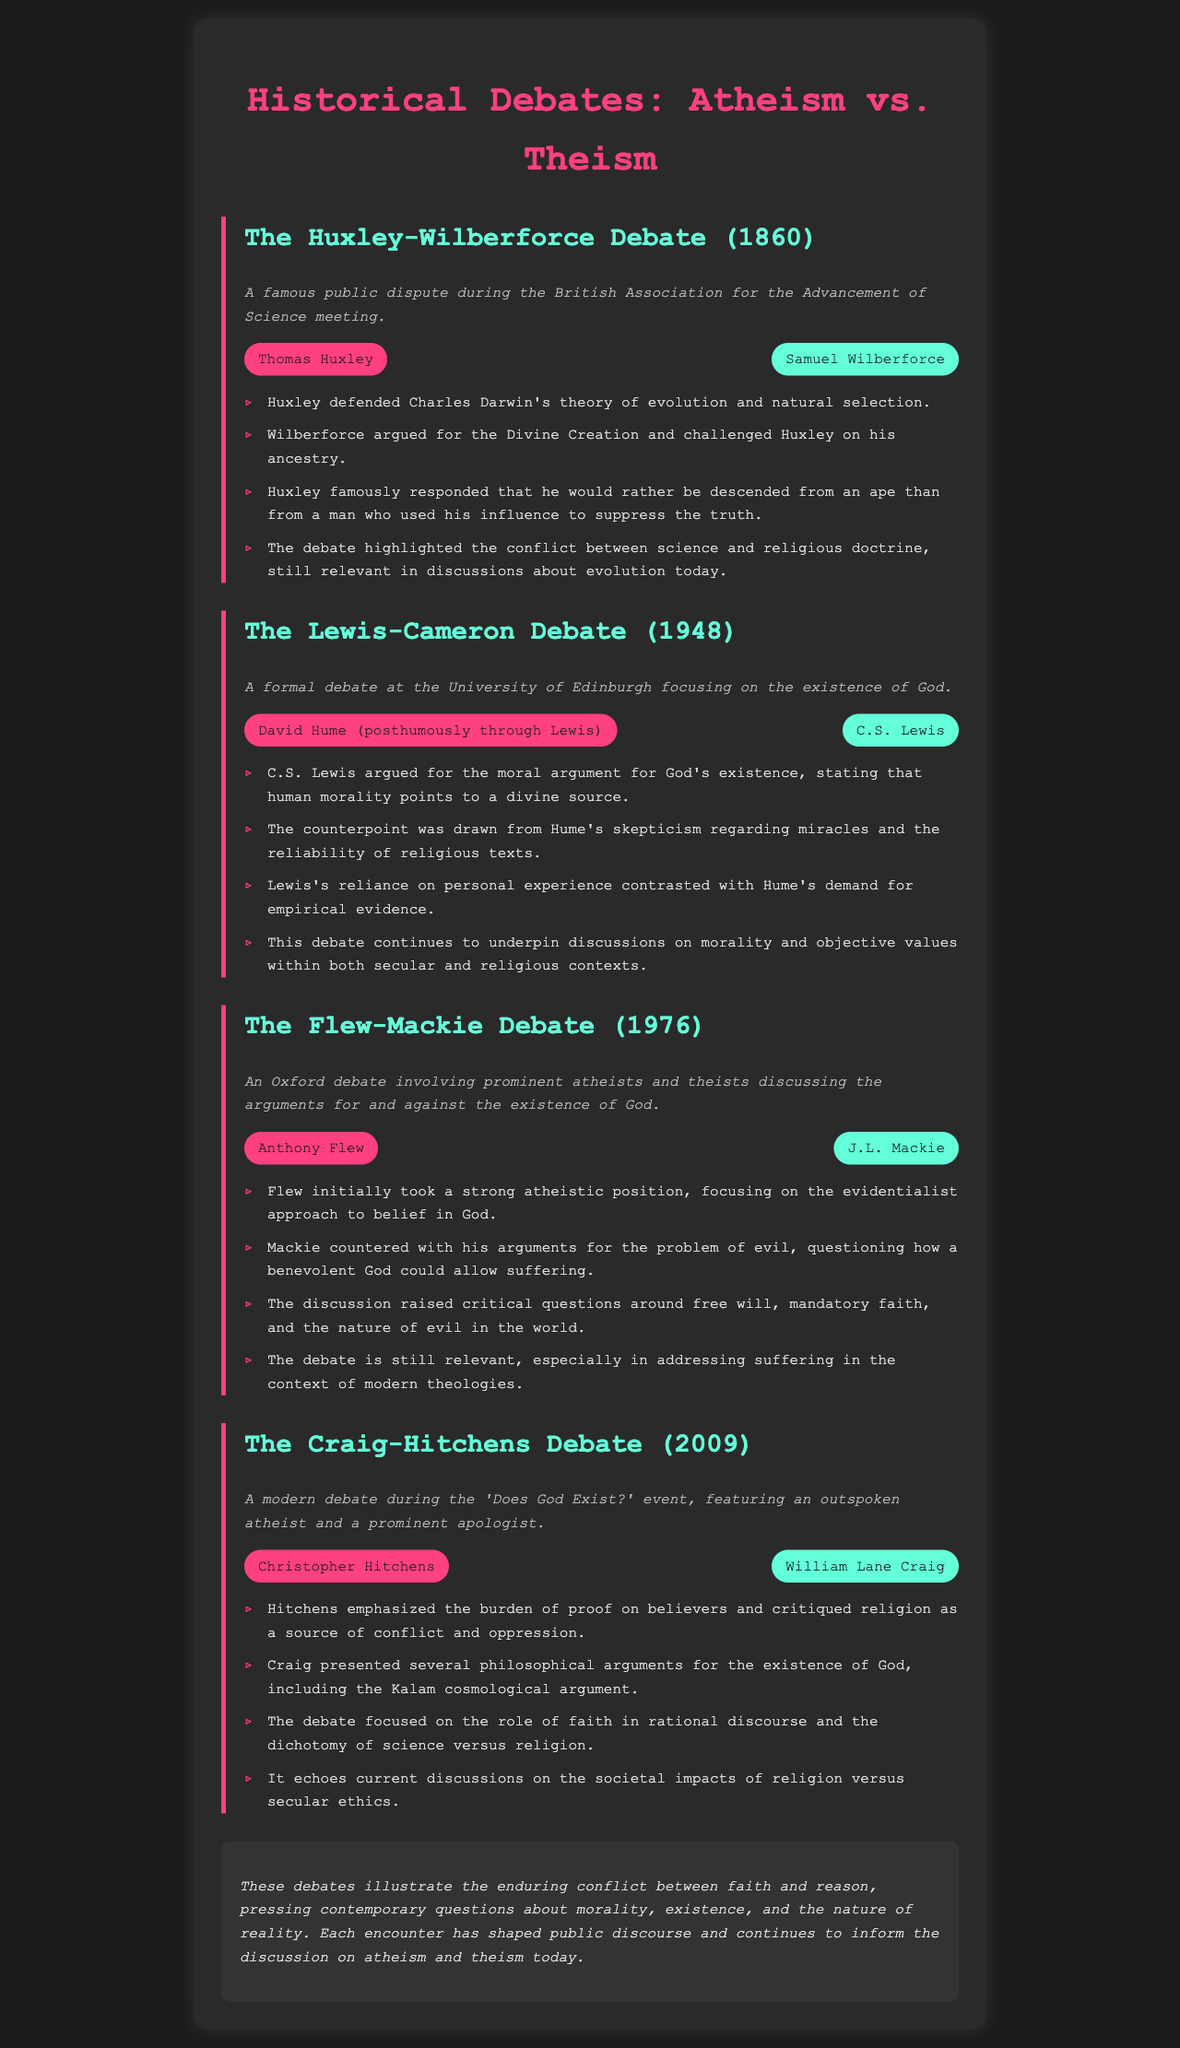What is the title of the document? The title of the document is found in the header of the page.
Answer: Historical Debates: Atheism vs. Theism Who were the participants in the Huxley-Wilberforce debate? The participants are listed in the subheading of the debate section.
Answer: Thomas Huxley and Samuel Wilberforce In what year did the Lewis-Cameron debate take place? The year of the debate is mentioned in the context paragraph.
Answer: 1948 What argument did C.S. Lewis present in his debate? The specific argument he presented is noted in the bullet points under the debate section.
Answer: Moral argument for God's existence What critical question did Mackie raise during the Flew-Mackie debate? The question he raised is explicitly mentioned in the provided points.
Answer: Problem of evil What was Christopher Hitchens's main critique of religion in his debate? The critique is summarized in one of the bullet points.
Answer: Religion as a source of conflict and oppression Which cosmological argument did William Lane Craig present? The cosmological argument is specifically noted in the discussion points.
Answer: Kalam cosmological argument What overarching theme is highlighted in the conclusion? The theme is summarized in the last section of the document.
Answer: Conflict between faith and reason 